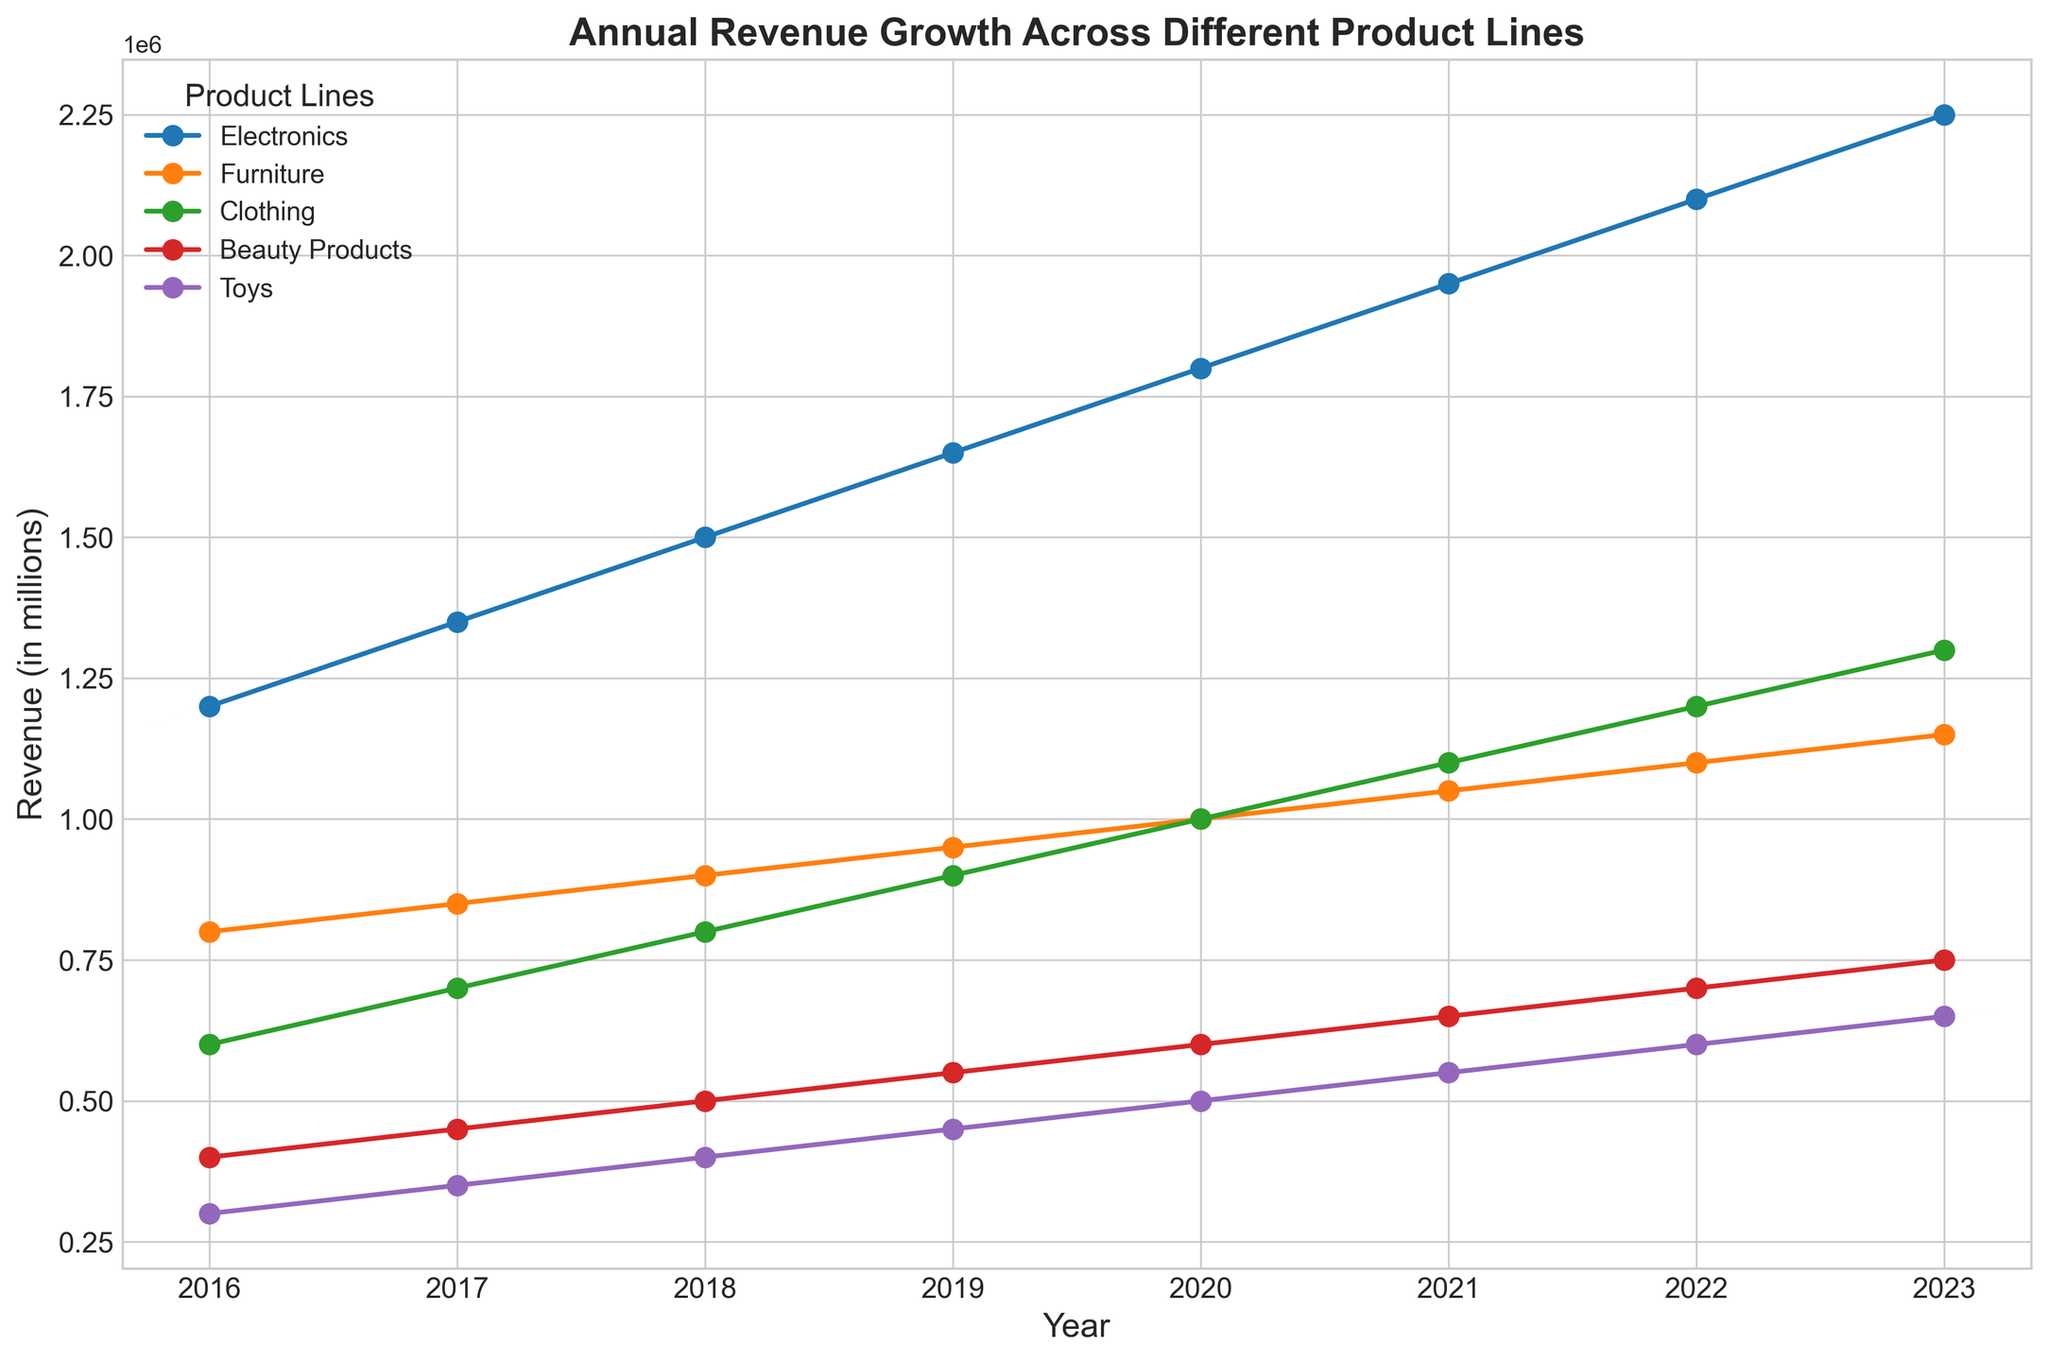Which product line showed the highest revenue in 2023? To identify which product line had the highest revenue in 2023, observe the endpoints of the lines on the right side of the chart and compare their values. The Electronics line is the highest.
Answer: Electronics Which product line had the most consistent increase in revenue from 2016 to 2023? Observe all the lines from 2016 to 2023 and identify the line that shows a steady, consistent upward trend. The Furniture line shows a steady, consistent increase without any abrupt changes.
Answer: Furniture By how much did the revenue for Clothing grow from 2016 to 2023? Subtract the 2016 revenue value for Clothing from the 2023 revenue value. The calculation is 1300000 - 600000 = 700000.
Answer: 700000 Which product line had the greatest percentage increase in revenue from 2016 to 2023? Calculate the percentage increase for each product line using the formula: ((Revenue in 2023 - Revenue in 2016) / Revenue in 2016) * 100. Evaluate the increases and compare them. Electronics: 87.5%, Furniture: 43.75%, Clothing: 116.67%, Beauty Products: 87.5%, Toys: 116.67%.
Answer: Clothing (Toys has the same percentage) Between 2018 and 2020, which product line had the highest revenue increase in absolute terms? Calculate the difference in revenue from 2018 to 2020 for each product line and compare them. Electronics: 300000, Furniture: 100000, Clothing: 200000, Beauty Products: 100000, Toys: 100000.
Answer: Electronics Which product line had the least growth in revenue from 2016 to 2023? Compare the differences in revenue from 2016 to 2023 for all product lines. The smallest difference is for Beauty Products, calculated as 750000 - 400000 = 350000.
Answer: Beauty Products In which year did Electronics achieve a revenue of 1.5 million? Locate the point on the Electronics line where the revenue corresponds to 1.5 million and identify the associated year. This point occurs in the year 2018.
Answer: 2018 How does the revenue growth of Toys in 2023 compare to its revenue in 2020? Calculate the difference between the revenue values of Toys in 2023 and 2020. The calculation is 650000 - 500000 = 150000.
Answer: 150000 larger Which two product lines had identical revenue increases from 2016 to 2023? Calculate the revenue increases from 2016 to 2023 for all product lines and find any matches. Electronics: 1050000, Furniture: 350000, Clothing: 700000, Beauty Products: 350000, Toys: 350000. Both Beauty Products and Toys had identical increases of 350000.
Answer: Beauty Products and Toys 